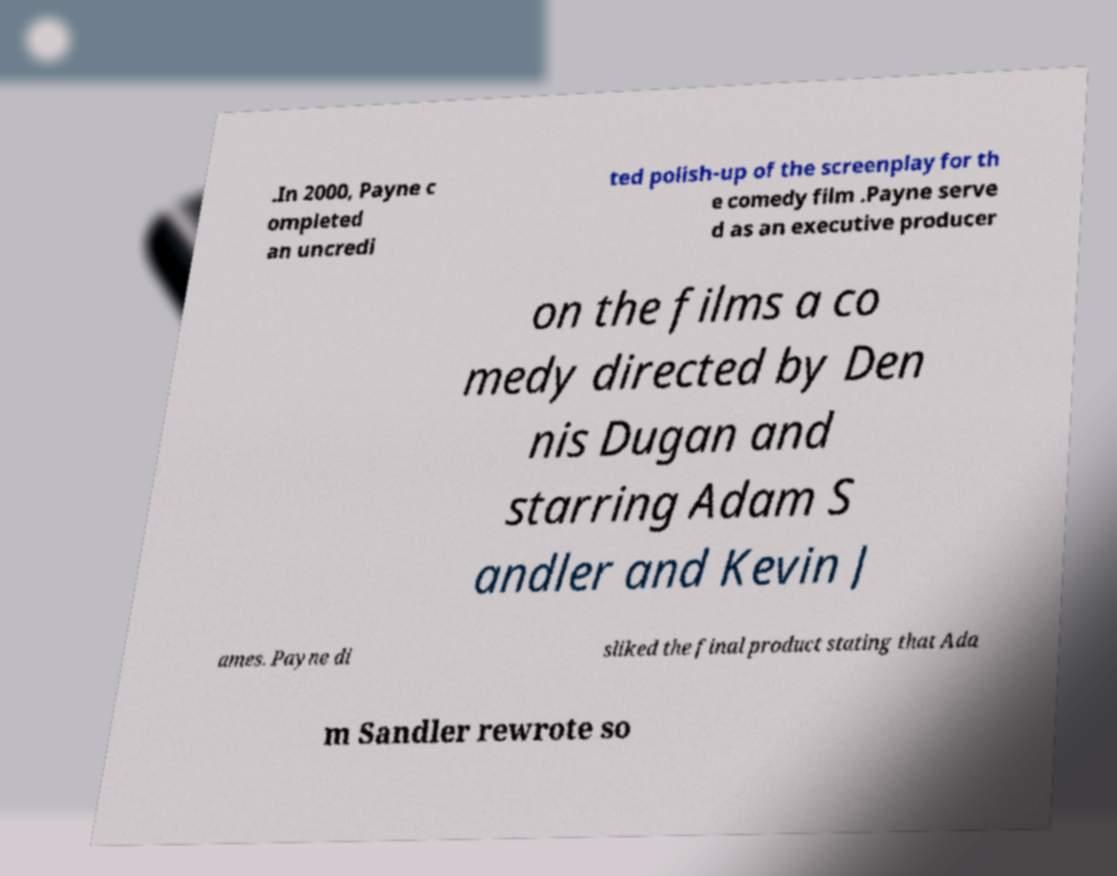For documentation purposes, I need the text within this image transcribed. Could you provide that? .In 2000, Payne c ompleted an uncredi ted polish-up of the screenplay for th e comedy film .Payne serve d as an executive producer on the films a co medy directed by Den nis Dugan and starring Adam S andler and Kevin J ames. Payne di sliked the final product stating that Ada m Sandler rewrote so 